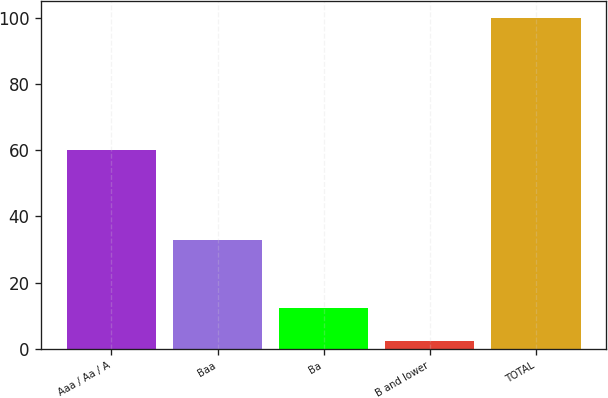Convert chart to OTSL. <chart><loc_0><loc_0><loc_500><loc_500><bar_chart><fcel>Aaa / Aa / A<fcel>Baa<fcel>Ba<fcel>B and lower<fcel>TOTAL<nl><fcel>60.1<fcel>33<fcel>12.16<fcel>2.4<fcel>100<nl></chart> 